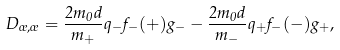<formula> <loc_0><loc_0><loc_500><loc_500>D _ { \sigma , \sigma } = \frac { 2 m _ { 0 } d } { m _ { + } } q _ { - } f _ { - } ( + ) g _ { - } - \frac { 2 m _ { 0 } d } { m _ { - } } q _ { + } f _ { - } ( - ) g _ { + } ,</formula> 